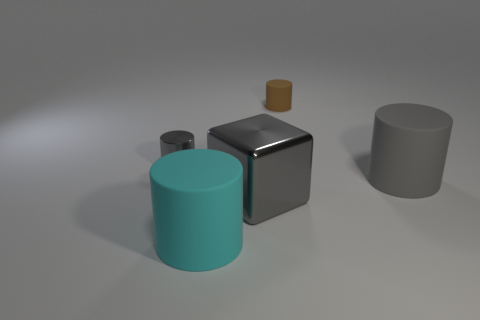Add 4 large cyan cylinders. How many objects exist? 9 Subtract all gray rubber cylinders. How many cylinders are left? 3 Subtract all cyan cylinders. How many cylinders are left? 3 Subtract all cylinders. How many objects are left? 1 Add 3 large cyan objects. How many large cyan objects exist? 4 Subtract 0 blue balls. How many objects are left? 5 Subtract 1 cylinders. How many cylinders are left? 3 Subtract all green cylinders. Subtract all gray blocks. How many cylinders are left? 4 Subtract all purple cubes. How many gray cylinders are left? 2 Subtract all tiny yellow metallic blocks. Subtract all large gray cylinders. How many objects are left? 4 